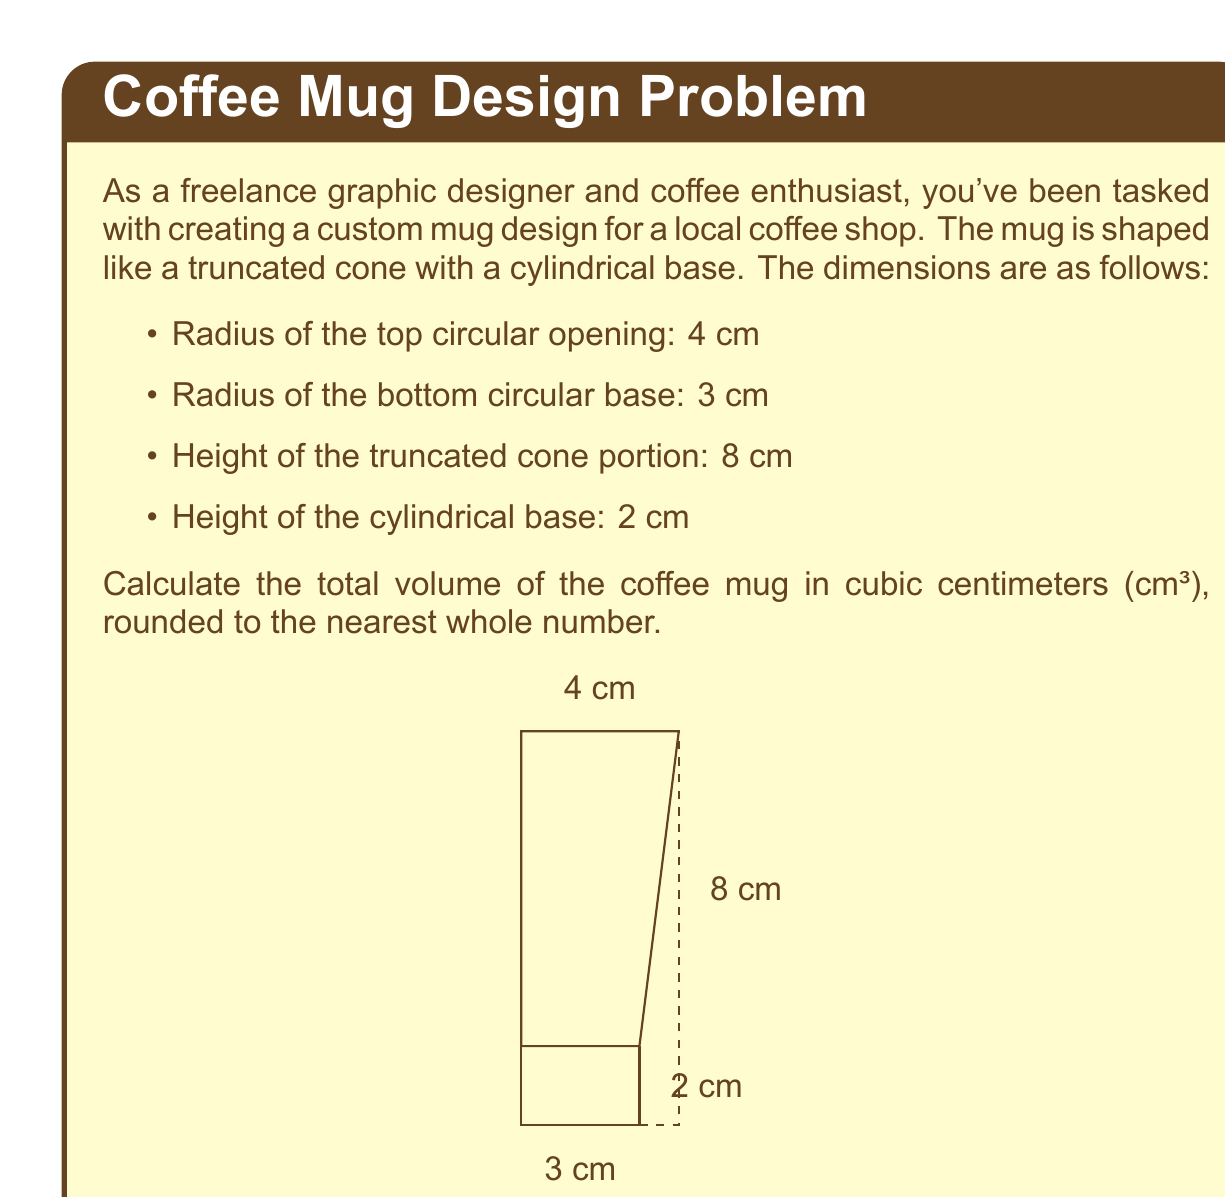Help me with this question. To calculate the total volume of the coffee mug, we need to find the volume of the truncated cone and the volume of the cylindrical base, then add them together.

1. Volume of the truncated cone:
   The formula for the volume of a truncated cone is:
   $$V_c = \frac{1}{3}\pi h(R^2 + r^2 + Rr)$$
   where $h$ is the height, $R$ is the radius of the larger circle, and $r$ is the radius of the smaller circle.

   Substituting the values:
   $$V_c = \frac{1}{3}\pi \cdot 8(4^2 + 3^2 + 4 \cdot 3)$$
   $$V_c = \frac{8\pi}{3}(16 + 9 + 12)$$
   $$V_c = \frac{8\pi}{3} \cdot 37$$
   $$V_c = 308.85 \text{ cm}^3$$

2. Volume of the cylindrical base:
   The formula for the volume of a cylinder is:
   $$V_b = \pi r^2 h$$
   where $r$ is the radius of the base and $h$ is the height.

   Substituting the values:
   $$V_b = \pi \cdot 3^2 \cdot 2$$
   $$V_b = 18\pi$$
   $$V_b = 56.55 \text{ cm}^3$$

3. Total volume:
   $$V_{\text{total}} = V_c + V_b$$
   $$V_{\text{total}} = 308.85 + 56.55$$
   $$V_{\text{total}} = 365.40 \text{ cm}^3$$

Rounding to the nearest whole number: 365 cm³
Answer: 365 cm³ 